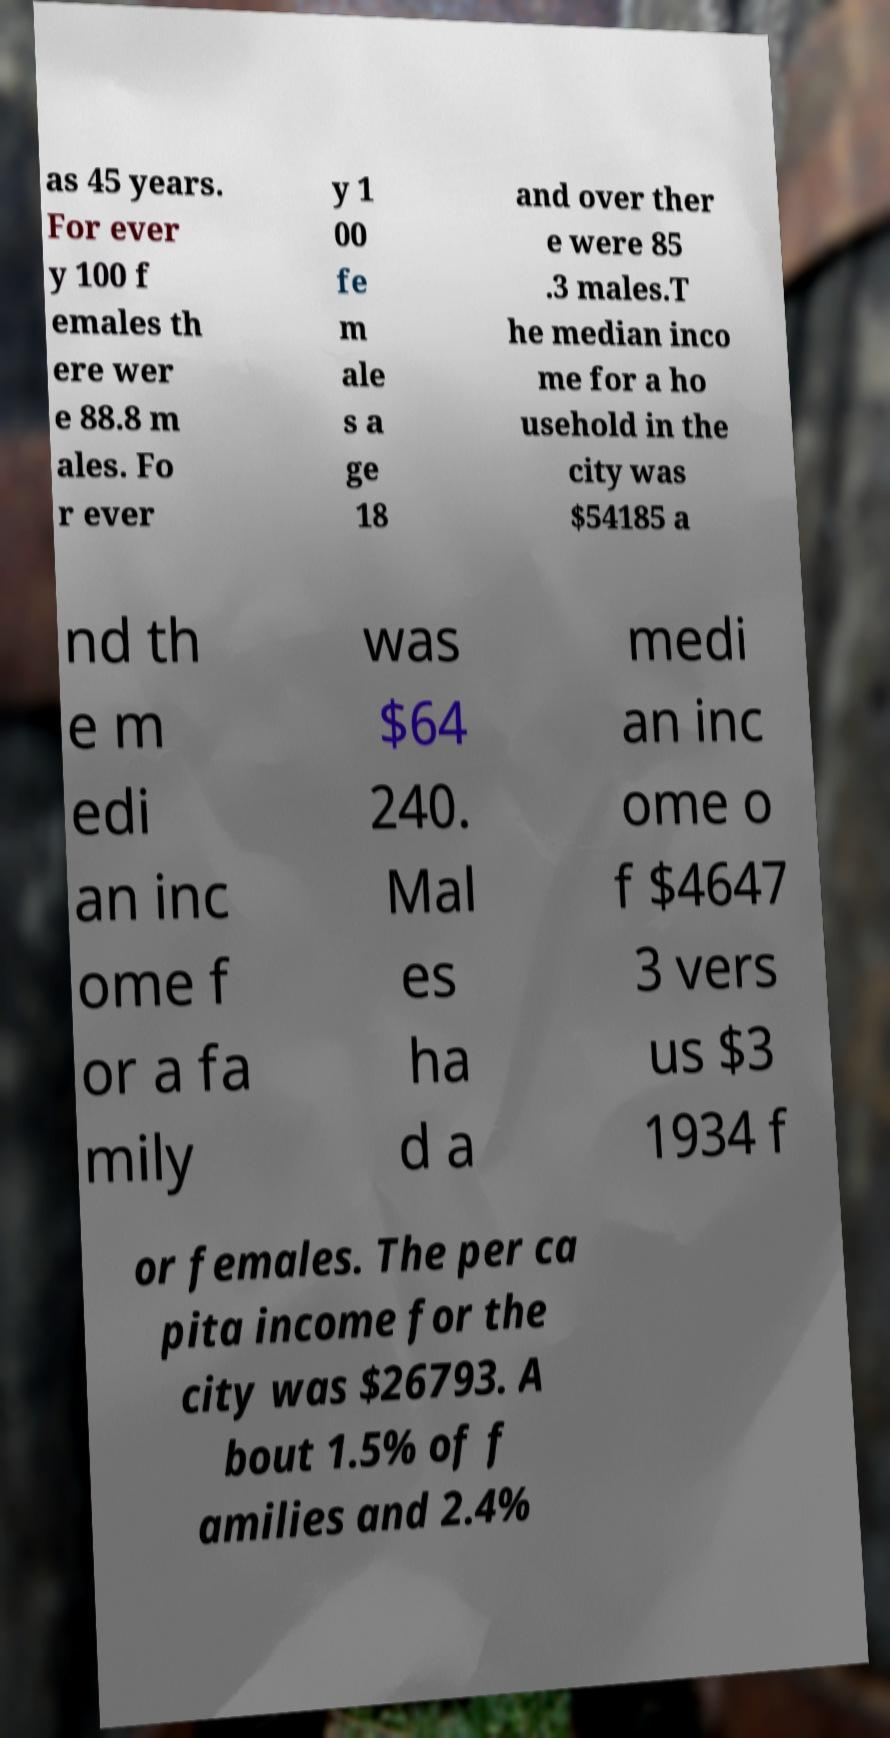I need the written content from this picture converted into text. Can you do that? as 45 years. For ever y 100 f emales th ere wer e 88.8 m ales. Fo r ever y 1 00 fe m ale s a ge 18 and over ther e were 85 .3 males.T he median inco me for a ho usehold in the city was $54185 a nd th e m edi an inc ome f or a fa mily was $64 240. Mal es ha d a medi an inc ome o f $4647 3 vers us $3 1934 f or females. The per ca pita income for the city was $26793. A bout 1.5% of f amilies and 2.4% 